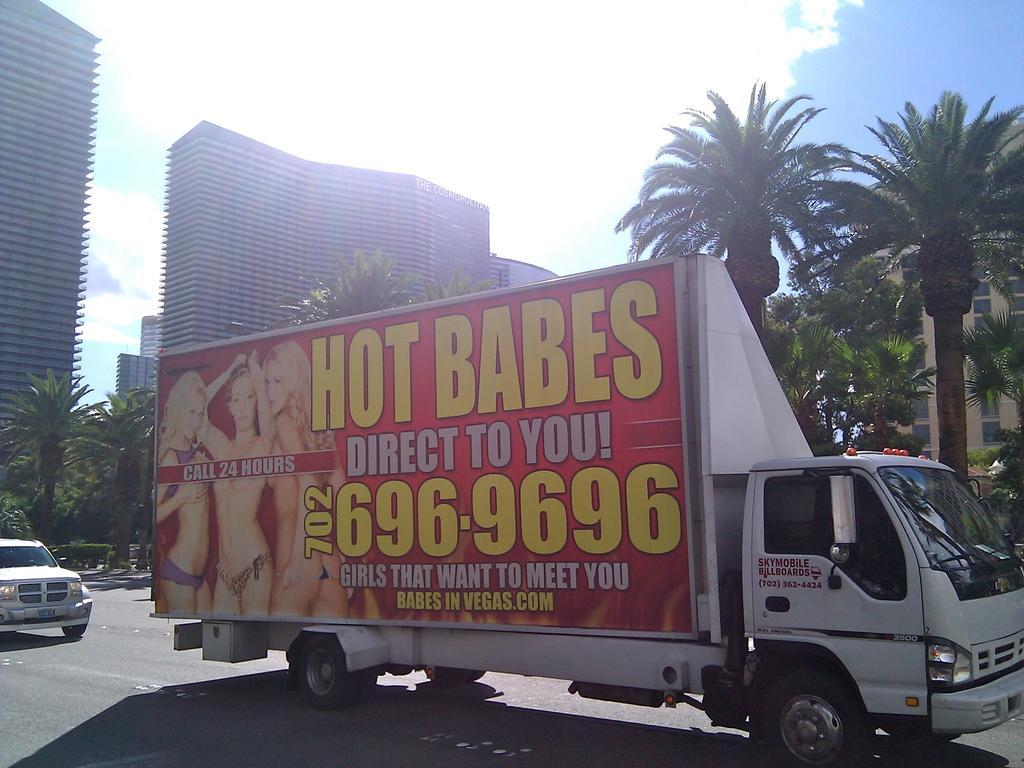Can you describe this image briefly? In the center of the image there is a truck. There are many trees. There are buildings. In the top of the image there is sky. In the bottom of the image there is road. 